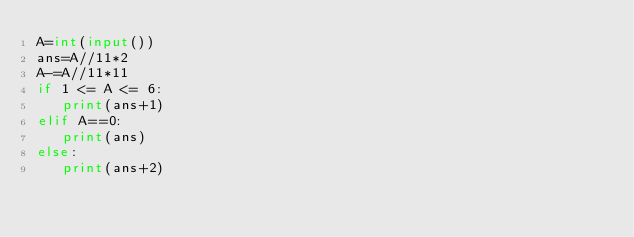<code> <loc_0><loc_0><loc_500><loc_500><_Python_>A=int(input())
ans=A//11*2
A-=A//11*11
if 1 <= A <= 6:
   print(ans+1)
elif A==0:
   print(ans)
else:
   print(ans+2)</code> 